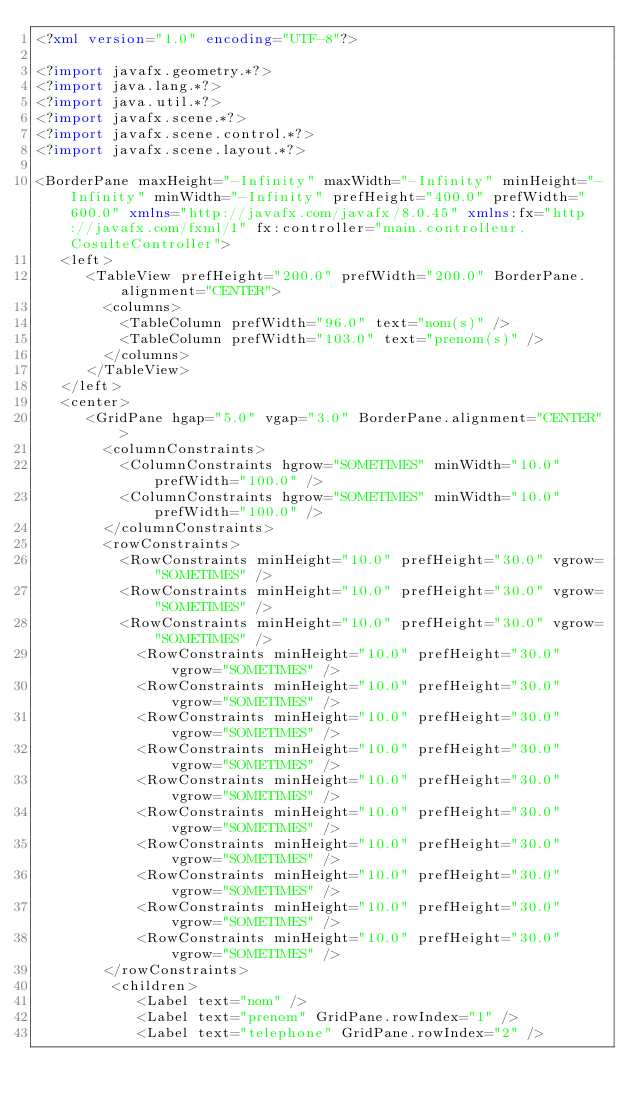<code> <loc_0><loc_0><loc_500><loc_500><_XML_><?xml version="1.0" encoding="UTF-8"?>

<?import javafx.geometry.*?>
<?import java.lang.*?>
<?import java.util.*?>
<?import javafx.scene.*?>
<?import javafx.scene.control.*?>
<?import javafx.scene.layout.*?>

<BorderPane maxHeight="-Infinity" maxWidth="-Infinity" minHeight="-Infinity" minWidth="-Infinity" prefHeight="400.0" prefWidth="600.0" xmlns="http://javafx.com/javafx/8.0.45" xmlns:fx="http://javafx.com/fxml/1" fx:controller="main.controlleur.CosulteController">
   <left>
      <TableView prefHeight="200.0" prefWidth="200.0" BorderPane.alignment="CENTER">
        <columns>
          <TableColumn prefWidth="96.0" text="nom(s)" />
          <TableColumn prefWidth="103.0" text="prenom(s)" />
        </columns>
      </TableView>
   </left>
   <center>
      <GridPane hgap="5.0" vgap="3.0" BorderPane.alignment="CENTER">
        <columnConstraints>
          <ColumnConstraints hgrow="SOMETIMES" minWidth="10.0" prefWidth="100.0" />
          <ColumnConstraints hgrow="SOMETIMES" minWidth="10.0" prefWidth="100.0" />
        </columnConstraints>
        <rowConstraints>
          <RowConstraints minHeight="10.0" prefHeight="30.0" vgrow="SOMETIMES" />
          <RowConstraints minHeight="10.0" prefHeight="30.0" vgrow="SOMETIMES" />
          <RowConstraints minHeight="10.0" prefHeight="30.0" vgrow="SOMETIMES" />
            <RowConstraints minHeight="10.0" prefHeight="30.0" vgrow="SOMETIMES" />
            <RowConstraints minHeight="10.0" prefHeight="30.0" vgrow="SOMETIMES" />
            <RowConstraints minHeight="10.0" prefHeight="30.0" vgrow="SOMETIMES" />
            <RowConstraints minHeight="10.0" prefHeight="30.0" vgrow="SOMETIMES" />
            <RowConstraints minHeight="10.0" prefHeight="30.0" vgrow="SOMETIMES" />
            <RowConstraints minHeight="10.0" prefHeight="30.0" vgrow="SOMETIMES" />
            <RowConstraints minHeight="10.0" prefHeight="30.0" vgrow="SOMETIMES" />
            <RowConstraints minHeight="10.0" prefHeight="30.0" vgrow="SOMETIMES" />
            <RowConstraints minHeight="10.0" prefHeight="30.0" vgrow="SOMETIMES" />
            <RowConstraints minHeight="10.0" prefHeight="30.0" vgrow="SOMETIMES" />
        </rowConstraints>
         <children>
            <Label text="nom" />
            <Label text="prenom" GridPane.rowIndex="1" />
            <Label text="telephone" GridPane.rowIndex="2" /></code> 